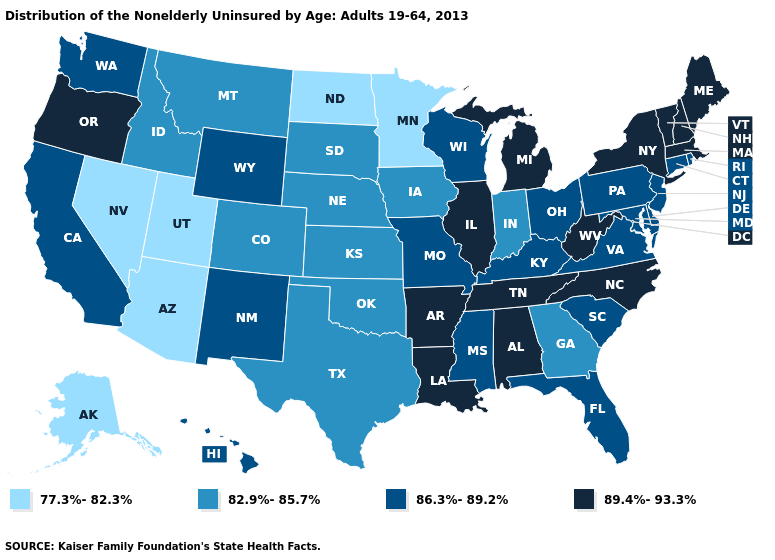Does the map have missing data?
Quick response, please. No. Among the states that border Florida , does Alabama have the lowest value?
Quick response, please. No. Name the states that have a value in the range 77.3%-82.3%?
Answer briefly. Alaska, Arizona, Minnesota, Nevada, North Dakota, Utah. What is the highest value in the MidWest ?
Answer briefly. 89.4%-93.3%. What is the lowest value in the MidWest?
Be succinct. 77.3%-82.3%. What is the value of Arizona?
Short answer required. 77.3%-82.3%. Does the first symbol in the legend represent the smallest category?
Write a very short answer. Yes. Does Nevada have a lower value than New York?
Answer briefly. Yes. What is the value of Arizona?
Concise answer only. 77.3%-82.3%. Does Idaho have the lowest value in the USA?
Give a very brief answer. No. Does Missouri have a higher value than Utah?
Write a very short answer. Yes. Among the states that border Iowa , does Illinois have the highest value?
Give a very brief answer. Yes. Which states hav the highest value in the MidWest?
Keep it brief. Illinois, Michigan. Which states have the lowest value in the Northeast?
Answer briefly. Connecticut, New Jersey, Pennsylvania, Rhode Island. Among the states that border Kentucky , which have the highest value?
Be succinct. Illinois, Tennessee, West Virginia. 